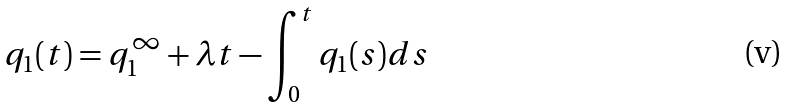Convert formula to latex. <formula><loc_0><loc_0><loc_500><loc_500>q _ { 1 } ( t ) = q _ { 1 } ^ { \infty } + \lambda t - \int _ { 0 } ^ { t } q _ { 1 } ( s ) d s</formula> 